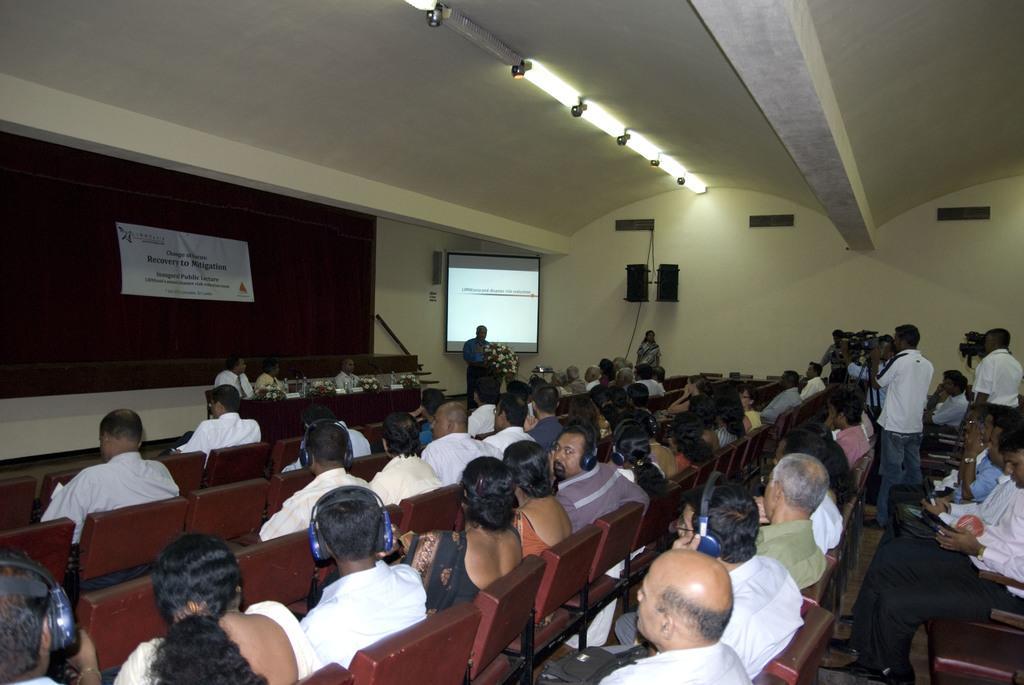Could you give a brief overview of what you see in this image? In this image I can see few people are sitting on the chairs. In front I can see a banner attached to the board. I can see few speakers, projector screen, lights and few people are holding cameras. 